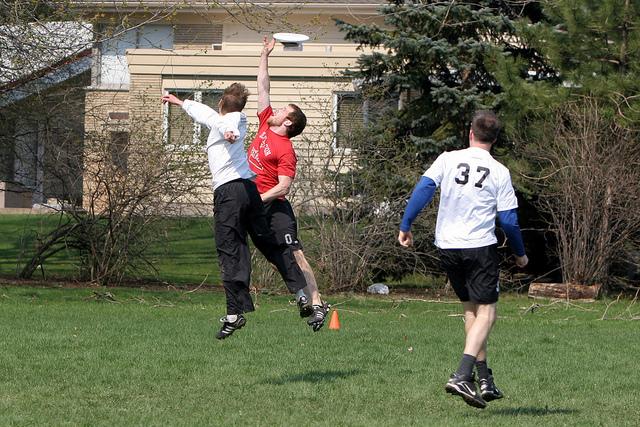What number is on the Jersey of the kid jumping?
Keep it brief. 37. What are they doing?
Give a very brief answer. Playing frisbee. Are they on the grass?
Give a very brief answer. Yes. Is this a contact sport?
Quick response, please. No. Are they standing on a playing field?
Short answer required. Yes. Who is closer to the frisbee?
Quick response, please. Man in red. 